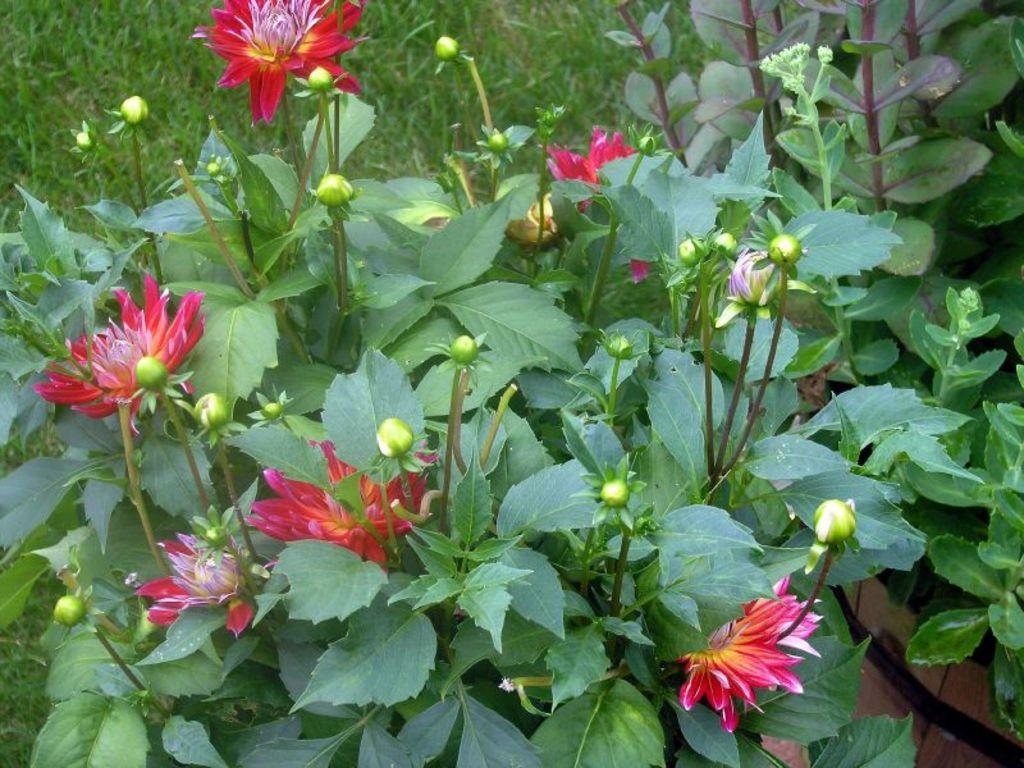What type of living organisms can be seen in the image? Plants can be seen in the image. What specific features can be observed on the plants? The plants have flowers, buds, and leaves. What is visible in the background of the image? The background of the image includes grassland. How many apples can be seen hanging from the plants in the image? There are no apples present in the image; the plants have flowers, buds, and leaves. Can you tell me how many cups are being used to water the plants in the image? There is no mention of cups or watering in the image; it simply shows plants with flowers, buds, and leaves against a grassland background. 